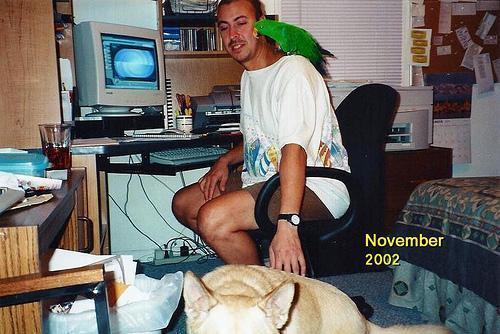How many people are there?
Give a very brief answer. 1. 